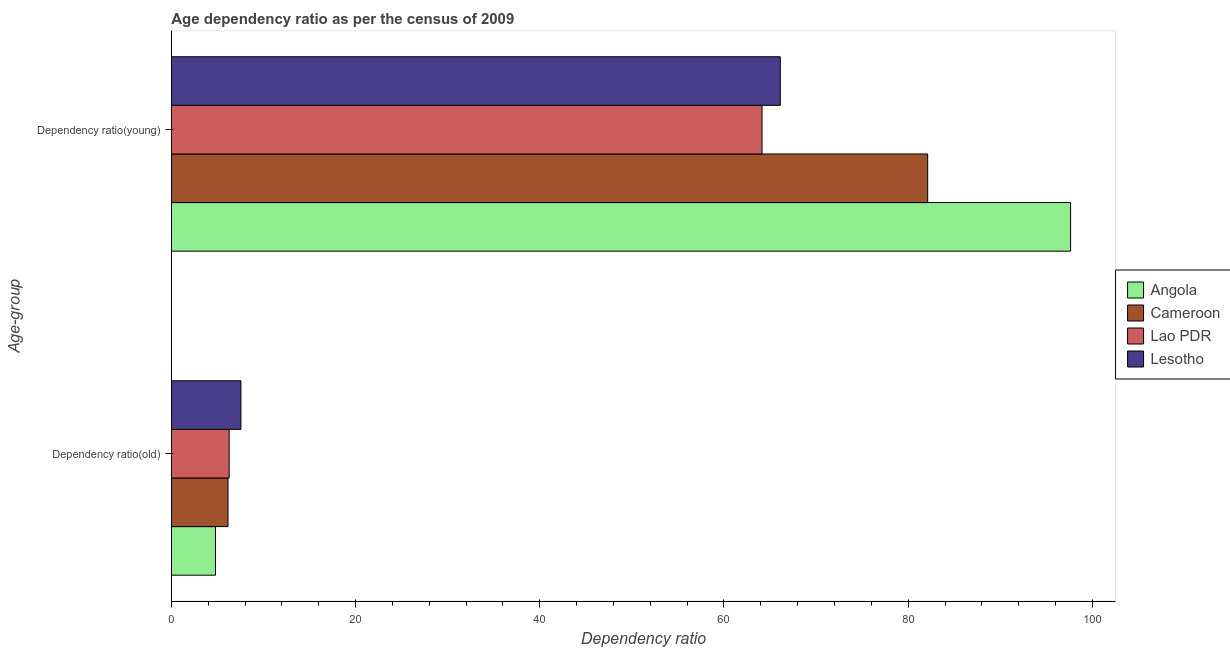How many different coloured bars are there?
Your response must be concise. 4. How many groups of bars are there?
Make the answer very short. 2. How many bars are there on the 2nd tick from the top?
Give a very brief answer. 4. How many bars are there on the 1st tick from the bottom?
Ensure brevity in your answer.  4. What is the label of the 1st group of bars from the top?
Ensure brevity in your answer.  Dependency ratio(young). What is the age dependency ratio(young) in Lesotho?
Make the answer very short. 66.12. Across all countries, what is the maximum age dependency ratio(young)?
Give a very brief answer. 97.64. Across all countries, what is the minimum age dependency ratio(old)?
Offer a very short reply. 4.79. In which country was the age dependency ratio(young) maximum?
Keep it short and to the point. Angola. In which country was the age dependency ratio(young) minimum?
Make the answer very short. Lao PDR. What is the total age dependency ratio(old) in the graph?
Your answer should be very brief. 24.76. What is the difference between the age dependency ratio(young) in Angola and that in Lesotho?
Provide a short and direct response. 31.52. What is the difference between the age dependency ratio(young) in Lao PDR and the age dependency ratio(old) in Lesotho?
Make the answer very short. 56.58. What is the average age dependency ratio(old) per country?
Provide a short and direct response. 6.19. What is the difference between the age dependency ratio(old) and age dependency ratio(young) in Lesotho?
Provide a succinct answer. -58.57. In how many countries, is the age dependency ratio(old) greater than 80 ?
Ensure brevity in your answer.  0. What is the ratio of the age dependency ratio(young) in Cameroon to that in Lao PDR?
Offer a terse response. 1.28. Is the age dependency ratio(young) in Angola less than that in Cameroon?
Provide a succinct answer. No. In how many countries, is the age dependency ratio(old) greater than the average age dependency ratio(old) taken over all countries?
Offer a very short reply. 2. What does the 3rd bar from the top in Dependency ratio(old) represents?
Give a very brief answer. Cameroon. What does the 1st bar from the bottom in Dependency ratio(young) represents?
Your answer should be very brief. Angola. Are all the bars in the graph horizontal?
Your response must be concise. Yes. What is the difference between two consecutive major ticks on the X-axis?
Offer a very short reply. 20. Does the graph contain any zero values?
Offer a terse response. No. What is the title of the graph?
Your answer should be compact. Age dependency ratio as per the census of 2009. What is the label or title of the X-axis?
Offer a terse response. Dependency ratio. What is the label or title of the Y-axis?
Make the answer very short. Age-group. What is the Dependency ratio in Angola in Dependency ratio(old)?
Make the answer very short. 4.79. What is the Dependency ratio of Cameroon in Dependency ratio(old)?
Your answer should be very brief. 6.15. What is the Dependency ratio in Lao PDR in Dependency ratio(old)?
Keep it short and to the point. 6.27. What is the Dependency ratio in Lesotho in Dependency ratio(old)?
Offer a terse response. 7.55. What is the Dependency ratio in Angola in Dependency ratio(young)?
Give a very brief answer. 97.64. What is the Dependency ratio of Cameroon in Dependency ratio(young)?
Your answer should be compact. 82.12. What is the Dependency ratio in Lao PDR in Dependency ratio(young)?
Your response must be concise. 64.13. What is the Dependency ratio of Lesotho in Dependency ratio(young)?
Your answer should be compact. 66.12. Across all Age-group, what is the maximum Dependency ratio in Angola?
Your answer should be very brief. 97.64. Across all Age-group, what is the maximum Dependency ratio in Cameroon?
Offer a very short reply. 82.12. Across all Age-group, what is the maximum Dependency ratio of Lao PDR?
Keep it short and to the point. 64.13. Across all Age-group, what is the maximum Dependency ratio of Lesotho?
Provide a succinct answer. 66.12. Across all Age-group, what is the minimum Dependency ratio of Angola?
Ensure brevity in your answer.  4.79. Across all Age-group, what is the minimum Dependency ratio in Cameroon?
Provide a short and direct response. 6.15. Across all Age-group, what is the minimum Dependency ratio of Lao PDR?
Your response must be concise. 6.27. Across all Age-group, what is the minimum Dependency ratio in Lesotho?
Keep it short and to the point. 7.55. What is the total Dependency ratio in Angola in the graph?
Provide a short and direct response. 102.43. What is the total Dependency ratio of Cameroon in the graph?
Give a very brief answer. 88.27. What is the total Dependency ratio in Lao PDR in the graph?
Offer a very short reply. 70.41. What is the total Dependency ratio of Lesotho in the graph?
Your answer should be compact. 73.67. What is the difference between the Dependency ratio of Angola in Dependency ratio(old) and that in Dependency ratio(young)?
Make the answer very short. -92.85. What is the difference between the Dependency ratio of Cameroon in Dependency ratio(old) and that in Dependency ratio(young)?
Your answer should be very brief. -75.97. What is the difference between the Dependency ratio in Lao PDR in Dependency ratio(old) and that in Dependency ratio(young)?
Give a very brief answer. -57.86. What is the difference between the Dependency ratio of Lesotho in Dependency ratio(old) and that in Dependency ratio(young)?
Ensure brevity in your answer.  -58.57. What is the difference between the Dependency ratio of Angola in Dependency ratio(old) and the Dependency ratio of Cameroon in Dependency ratio(young)?
Offer a very short reply. -77.33. What is the difference between the Dependency ratio in Angola in Dependency ratio(old) and the Dependency ratio in Lao PDR in Dependency ratio(young)?
Offer a very short reply. -59.34. What is the difference between the Dependency ratio of Angola in Dependency ratio(old) and the Dependency ratio of Lesotho in Dependency ratio(young)?
Provide a succinct answer. -61.33. What is the difference between the Dependency ratio of Cameroon in Dependency ratio(old) and the Dependency ratio of Lao PDR in Dependency ratio(young)?
Your response must be concise. -57.99. What is the difference between the Dependency ratio of Cameroon in Dependency ratio(old) and the Dependency ratio of Lesotho in Dependency ratio(young)?
Your answer should be very brief. -59.97. What is the difference between the Dependency ratio of Lao PDR in Dependency ratio(old) and the Dependency ratio of Lesotho in Dependency ratio(young)?
Your answer should be compact. -59.84. What is the average Dependency ratio in Angola per Age-group?
Offer a very short reply. 51.21. What is the average Dependency ratio in Cameroon per Age-group?
Provide a short and direct response. 44.13. What is the average Dependency ratio of Lao PDR per Age-group?
Provide a short and direct response. 35.2. What is the average Dependency ratio of Lesotho per Age-group?
Offer a very short reply. 36.83. What is the difference between the Dependency ratio of Angola and Dependency ratio of Cameroon in Dependency ratio(old)?
Your response must be concise. -1.36. What is the difference between the Dependency ratio in Angola and Dependency ratio in Lao PDR in Dependency ratio(old)?
Provide a succinct answer. -1.48. What is the difference between the Dependency ratio of Angola and Dependency ratio of Lesotho in Dependency ratio(old)?
Your answer should be compact. -2.76. What is the difference between the Dependency ratio in Cameroon and Dependency ratio in Lao PDR in Dependency ratio(old)?
Provide a short and direct response. -0.13. What is the difference between the Dependency ratio in Cameroon and Dependency ratio in Lesotho in Dependency ratio(old)?
Make the answer very short. -1.4. What is the difference between the Dependency ratio in Lao PDR and Dependency ratio in Lesotho in Dependency ratio(old)?
Ensure brevity in your answer.  -1.28. What is the difference between the Dependency ratio in Angola and Dependency ratio in Cameroon in Dependency ratio(young)?
Make the answer very short. 15.52. What is the difference between the Dependency ratio in Angola and Dependency ratio in Lao PDR in Dependency ratio(young)?
Provide a short and direct response. 33.51. What is the difference between the Dependency ratio in Angola and Dependency ratio in Lesotho in Dependency ratio(young)?
Your answer should be very brief. 31.52. What is the difference between the Dependency ratio in Cameroon and Dependency ratio in Lao PDR in Dependency ratio(young)?
Offer a very short reply. 17.99. What is the difference between the Dependency ratio in Cameroon and Dependency ratio in Lesotho in Dependency ratio(young)?
Offer a very short reply. 16. What is the difference between the Dependency ratio in Lao PDR and Dependency ratio in Lesotho in Dependency ratio(young)?
Your answer should be compact. -1.98. What is the ratio of the Dependency ratio in Angola in Dependency ratio(old) to that in Dependency ratio(young)?
Provide a succinct answer. 0.05. What is the ratio of the Dependency ratio in Cameroon in Dependency ratio(old) to that in Dependency ratio(young)?
Ensure brevity in your answer.  0.07. What is the ratio of the Dependency ratio in Lao PDR in Dependency ratio(old) to that in Dependency ratio(young)?
Your response must be concise. 0.1. What is the ratio of the Dependency ratio in Lesotho in Dependency ratio(old) to that in Dependency ratio(young)?
Your response must be concise. 0.11. What is the difference between the highest and the second highest Dependency ratio of Angola?
Your answer should be compact. 92.85. What is the difference between the highest and the second highest Dependency ratio in Cameroon?
Make the answer very short. 75.97. What is the difference between the highest and the second highest Dependency ratio of Lao PDR?
Your answer should be compact. 57.86. What is the difference between the highest and the second highest Dependency ratio of Lesotho?
Ensure brevity in your answer.  58.57. What is the difference between the highest and the lowest Dependency ratio of Angola?
Provide a succinct answer. 92.85. What is the difference between the highest and the lowest Dependency ratio in Cameroon?
Make the answer very short. 75.97. What is the difference between the highest and the lowest Dependency ratio in Lao PDR?
Your answer should be compact. 57.86. What is the difference between the highest and the lowest Dependency ratio of Lesotho?
Your answer should be compact. 58.57. 